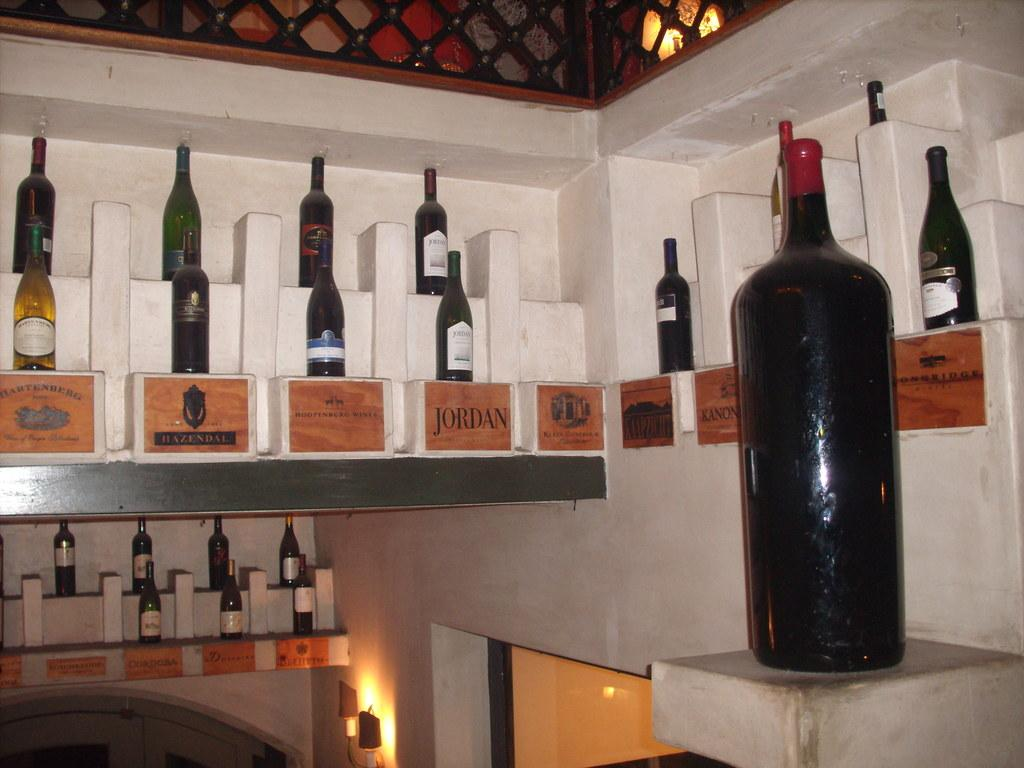<image>
Create a compact narrative representing the image presented. A bottle of Jordan wine is displayed along with several other wines. 